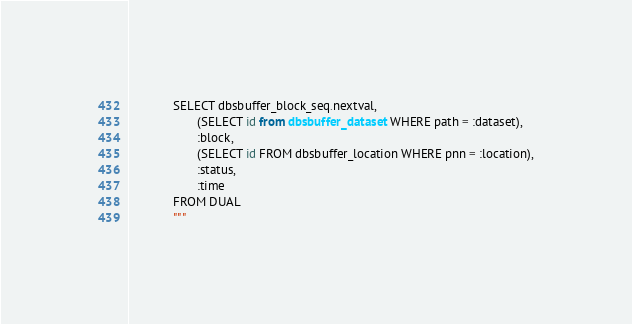Convert code to text. <code><loc_0><loc_0><loc_500><loc_500><_Python_>             SELECT dbsbuffer_block_seq.nextval,
                    (SELECT id from dbsbuffer_dataset WHERE path = :dataset),
                    :block,
                    (SELECT id FROM dbsbuffer_location WHERE pnn = :location),
                    :status,
                    :time
             FROM DUAL
             """
</code> 